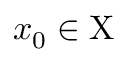Convert formula to latex. <formula><loc_0><loc_0><loc_500><loc_500>x _ { 0 } \in X</formula> 